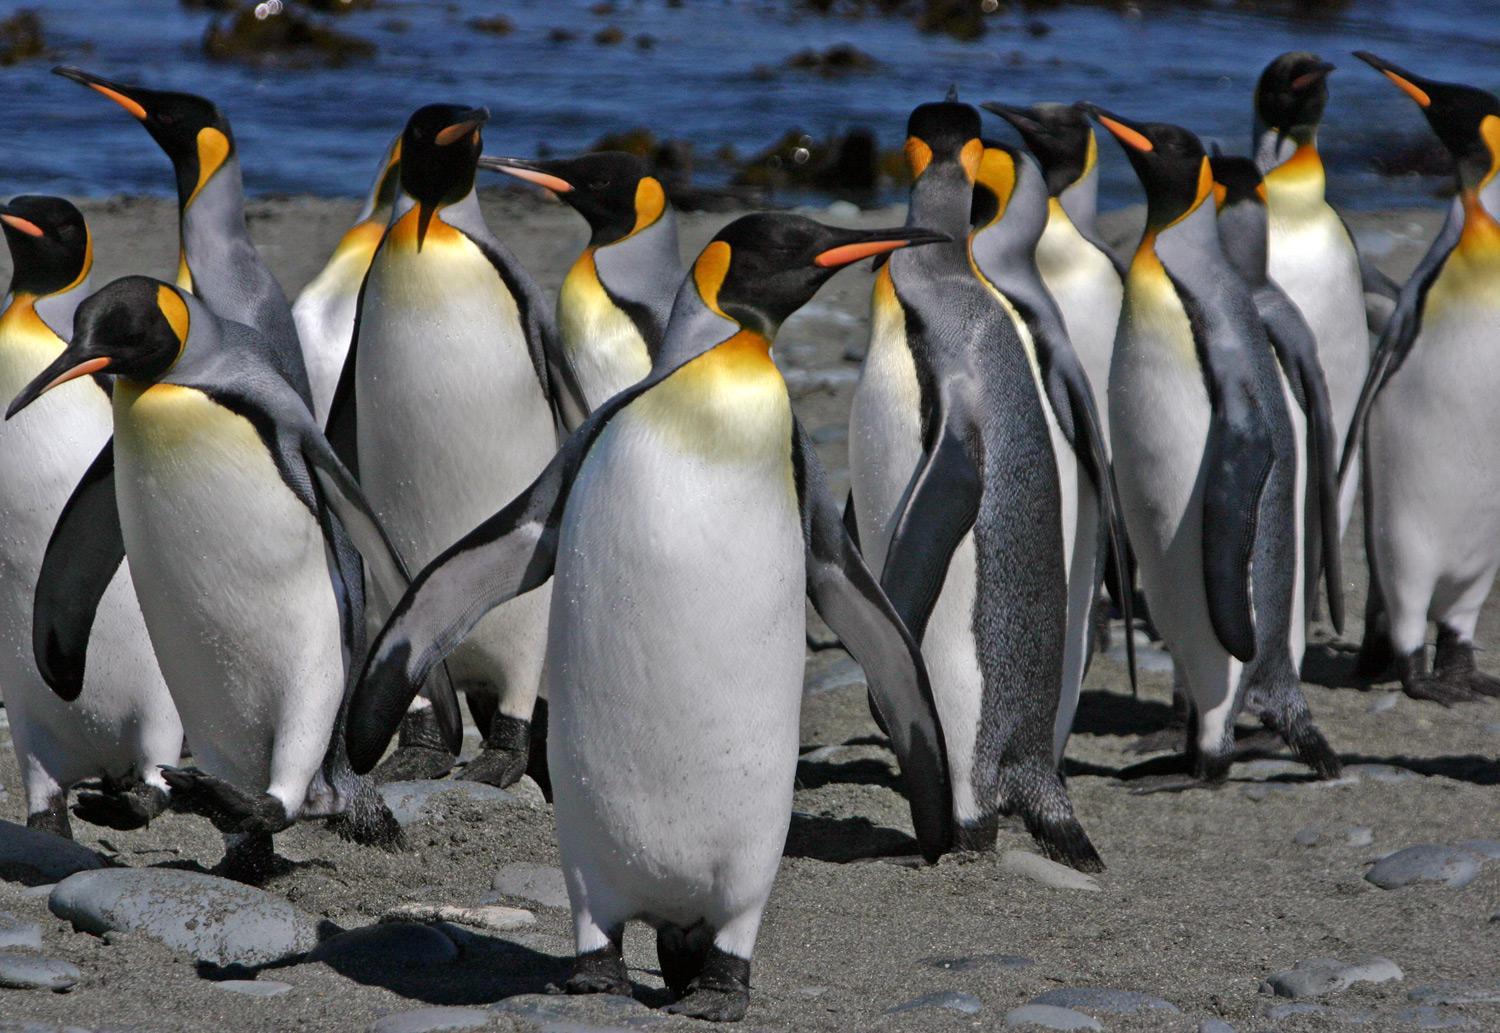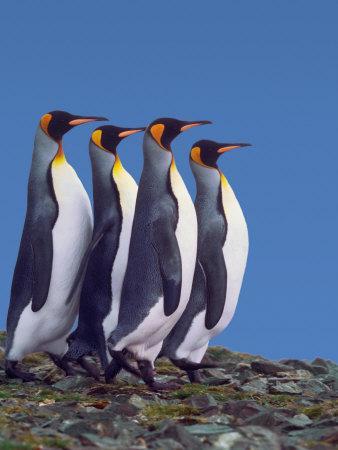The first image is the image on the left, the second image is the image on the right. Given the left and right images, does the statement "Each image shows exactly two penguins posed close together." hold true? Answer yes or no. No. The first image is the image on the left, the second image is the image on the right. For the images shown, is this caption "There are at most 4 penguins total in both images." true? Answer yes or no. No. The first image is the image on the left, the second image is the image on the right. Considering the images on both sides, is "There are no more than two animals in the image on the right." valid? Answer yes or no. No. The first image is the image on the left, the second image is the image on the right. Considering the images on both sides, is "There are four penguins in total." valid? Answer yes or no. No. 